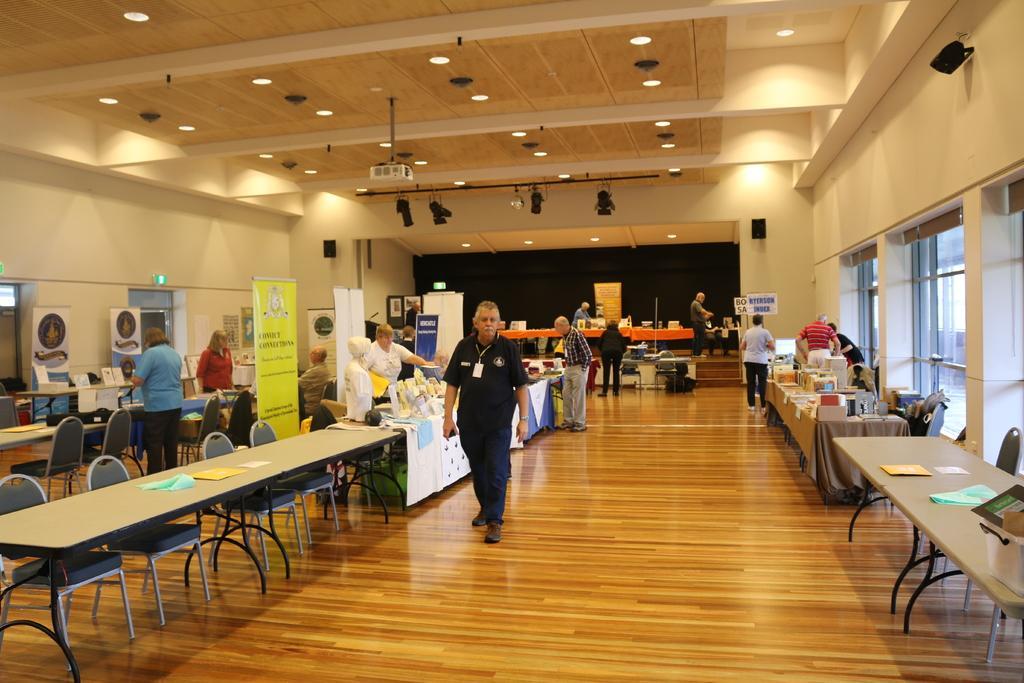Please provide a concise description of this image. In this picture we can see here roof and lights, and table on the floor and papers on it here is the hoardings, and chairs, and tables and the person is standing and wearing an id card, and here is staircase here is the group of people discussing, here is a woman standing and here is the man sitting. 